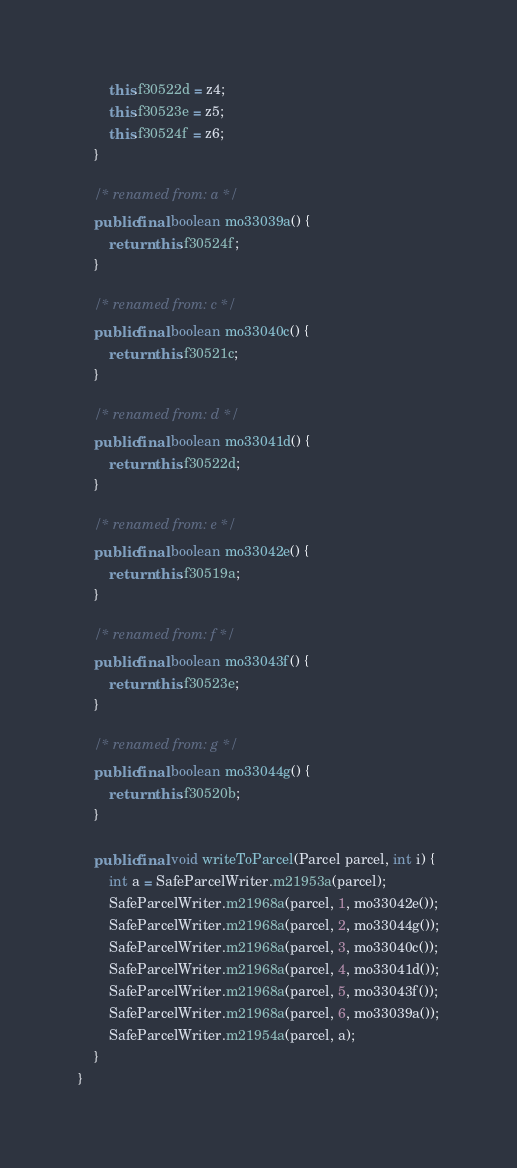Convert code to text. <code><loc_0><loc_0><loc_500><loc_500><_Java_>        this.f30522d = z4;
        this.f30523e = z5;
        this.f30524f = z6;
    }

    /* renamed from: a */
    public final boolean mo33039a() {
        return this.f30524f;
    }

    /* renamed from: c */
    public final boolean mo33040c() {
        return this.f30521c;
    }

    /* renamed from: d */
    public final boolean mo33041d() {
        return this.f30522d;
    }

    /* renamed from: e */
    public final boolean mo33042e() {
        return this.f30519a;
    }

    /* renamed from: f */
    public final boolean mo33043f() {
        return this.f30523e;
    }

    /* renamed from: g */
    public final boolean mo33044g() {
        return this.f30520b;
    }

    public final void writeToParcel(Parcel parcel, int i) {
        int a = SafeParcelWriter.m21953a(parcel);
        SafeParcelWriter.m21968a(parcel, 1, mo33042e());
        SafeParcelWriter.m21968a(parcel, 2, mo33044g());
        SafeParcelWriter.m21968a(parcel, 3, mo33040c());
        SafeParcelWriter.m21968a(parcel, 4, mo33041d());
        SafeParcelWriter.m21968a(parcel, 5, mo33043f());
        SafeParcelWriter.m21968a(parcel, 6, mo33039a());
        SafeParcelWriter.m21954a(parcel, a);
    }
}
</code> 